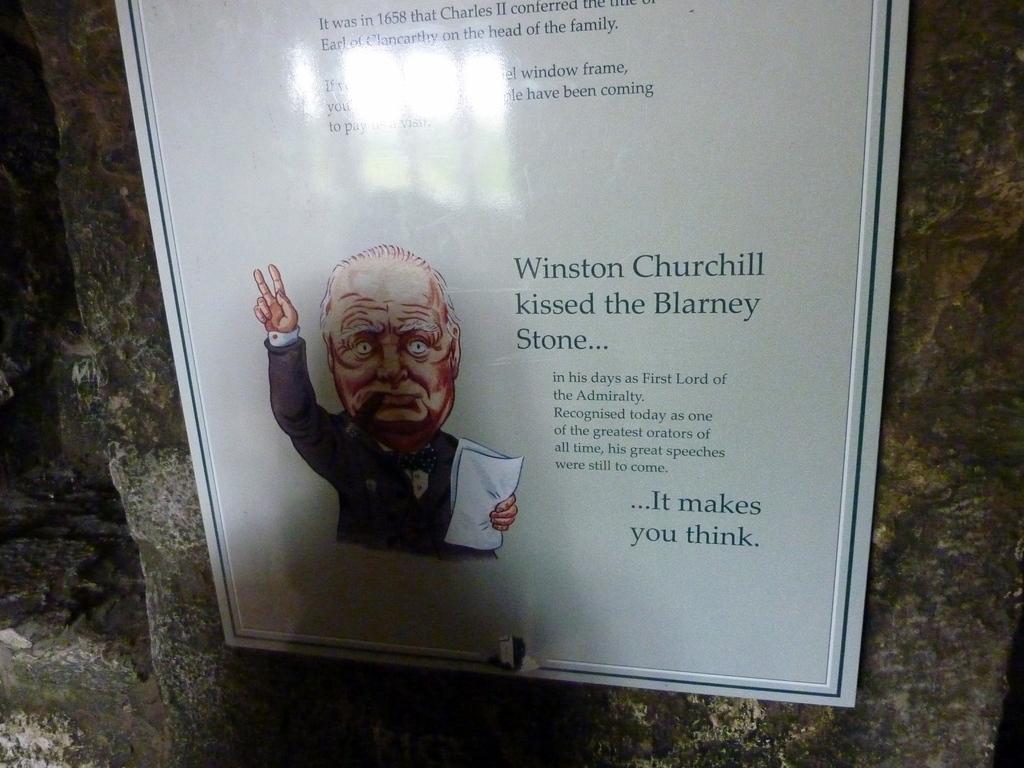Can you describe this image briefly? Here we can see a board on the wall. On this board we can see picture of a person and text written on it. 